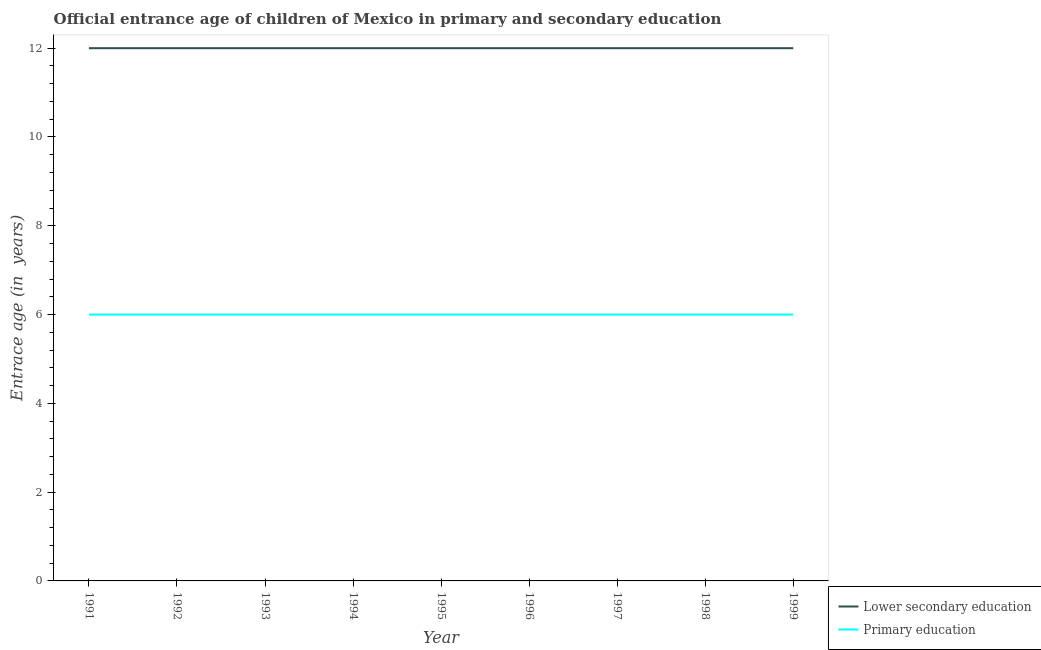Does the line corresponding to entrance age of children in lower secondary education intersect with the line corresponding to entrance age of chiildren in primary education?
Make the answer very short. No. Is the number of lines equal to the number of legend labels?
Keep it short and to the point. Yes. What is the entrance age of children in lower secondary education in 1991?
Your answer should be compact. 12. Across all years, what is the maximum entrance age of children in lower secondary education?
Provide a succinct answer. 12. Across all years, what is the minimum entrance age of chiildren in primary education?
Provide a succinct answer. 6. In which year was the entrance age of chiildren in primary education maximum?
Provide a short and direct response. 1991. In which year was the entrance age of children in lower secondary education minimum?
Make the answer very short. 1991. What is the total entrance age of chiildren in primary education in the graph?
Your answer should be compact. 54. What is the difference between the entrance age of chiildren in primary education in 1997 and the entrance age of children in lower secondary education in 1995?
Give a very brief answer. -6. In the year 1994, what is the difference between the entrance age of chiildren in primary education and entrance age of children in lower secondary education?
Make the answer very short. -6. In how many years, is the entrance age of children in lower secondary education greater than 8.4 years?
Give a very brief answer. 9. Is the difference between the entrance age of children in lower secondary education in 1993 and 1998 greater than the difference between the entrance age of chiildren in primary education in 1993 and 1998?
Your answer should be very brief. No. What is the difference between the highest and the lowest entrance age of chiildren in primary education?
Your response must be concise. 0. Is the sum of the entrance age of chiildren in primary education in 1997 and 1999 greater than the maximum entrance age of children in lower secondary education across all years?
Offer a terse response. No. Does the entrance age of children in lower secondary education monotonically increase over the years?
Your response must be concise. No. Is the entrance age of children in lower secondary education strictly greater than the entrance age of chiildren in primary education over the years?
Your answer should be very brief. Yes. How many lines are there?
Provide a succinct answer. 2. How many years are there in the graph?
Offer a very short reply. 9. What is the difference between two consecutive major ticks on the Y-axis?
Offer a terse response. 2. Are the values on the major ticks of Y-axis written in scientific E-notation?
Your response must be concise. No. Does the graph contain grids?
Provide a short and direct response. No. What is the title of the graph?
Ensure brevity in your answer.  Official entrance age of children of Mexico in primary and secondary education. Does "Passenger Transport Items" appear as one of the legend labels in the graph?
Your answer should be very brief. No. What is the label or title of the Y-axis?
Provide a succinct answer. Entrace age (in  years). What is the Entrace age (in  years) in Lower secondary education in 1991?
Keep it short and to the point. 12. What is the Entrace age (in  years) of Lower secondary education in 1992?
Your answer should be very brief. 12. What is the Entrace age (in  years) in Primary education in 1993?
Give a very brief answer. 6. What is the Entrace age (in  years) in Lower secondary education in 1994?
Your answer should be very brief. 12. What is the Entrace age (in  years) of Lower secondary education in 1995?
Provide a succinct answer. 12. What is the Entrace age (in  years) in Primary education in 1997?
Provide a short and direct response. 6. What is the total Entrace age (in  years) in Lower secondary education in the graph?
Provide a short and direct response. 108. What is the total Entrace age (in  years) of Primary education in the graph?
Ensure brevity in your answer.  54. What is the difference between the Entrace age (in  years) in Primary education in 1991 and that in 1992?
Ensure brevity in your answer.  0. What is the difference between the Entrace age (in  years) in Lower secondary education in 1991 and that in 1994?
Provide a short and direct response. 0. What is the difference between the Entrace age (in  years) of Primary education in 1991 and that in 1994?
Offer a terse response. 0. What is the difference between the Entrace age (in  years) in Lower secondary education in 1991 and that in 1996?
Provide a short and direct response. 0. What is the difference between the Entrace age (in  years) in Primary education in 1991 and that in 1996?
Your answer should be very brief. 0. What is the difference between the Entrace age (in  years) of Primary education in 1991 and that in 1997?
Provide a short and direct response. 0. What is the difference between the Entrace age (in  years) of Lower secondary education in 1991 and that in 1998?
Make the answer very short. 0. What is the difference between the Entrace age (in  years) in Primary education in 1991 and that in 1999?
Your answer should be compact. 0. What is the difference between the Entrace age (in  years) in Lower secondary education in 1992 and that in 1993?
Provide a short and direct response. 0. What is the difference between the Entrace age (in  years) in Primary education in 1992 and that in 1993?
Give a very brief answer. 0. What is the difference between the Entrace age (in  years) of Primary education in 1992 and that in 1994?
Offer a terse response. 0. What is the difference between the Entrace age (in  years) in Lower secondary education in 1992 and that in 1996?
Provide a succinct answer. 0. What is the difference between the Entrace age (in  years) in Primary education in 1992 and that in 1996?
Provide a short and direct response. 0. What is the difference between the Entrace age (in  years) in Primary education in 1992 and that in 1997?
Give a very brief answer. 0. What is the difference between the Entrace age (in  years) of Lower secondary education in 1992 and that in 1998?
Your response must be concise. 0. What is the difference between the Entrace age (in  years) of Lower secondary education in 1992 and that in 1999?
Provide a succinct answer. 0. What is the difference between the Entrace age (in  years) in Primary education in 1992 and that in 1999?
Your response must be concise. 0. What is the difference between the Entrace age (in  years) of Primary education in 1993 and that in 1995?
Offer a very short reply. 0. What is the difference between the Entrace age (in  years) in Lower secondary education in 1993 and that in 1996?
Make the answer very short. 0. What is the difference between the Entrace age (in  years) of Primary education in 1993 and that in 1996?
Keep it short and to the point. 0. What is the difference between the Entrace age (in  years) in Primary education in 1993 and that in 1997?
Your response must be concise. 0. What is the difference between the Entrace age (in  years) of Lower secondary education in 1993 and that in 1998?
Offer a very short reply. 0. What is the difference between the Entrace age (in  years) in Primary education in 1994 and that in 1995?
Provide a short and direct response. 0. What is the difference between the Entrace age (in  years) in Primary education in 1994 and that in 1996?
Provide a succinct answer. 0. What is the difference between the Entrace age (in  years) of Lower secondary education in 1994 and that in 1997?
Provide a short and direct response. 0. What is the difference between the Entrace age (in  years) in Lower secondary education in 1994 and that in 1999?
Make the answer very short. 0. What is the difference between the Entrace age (in  years) in Primary education in 1994 and that in 1999?
Make the answer very short. 0. What is the difference between the Entrace age (in  years) of Lower secondary education in 1995 and that in 1996?
Provide a succinct answer. 0. What is the difference between the Entrace age (in  years) in Primary education in 1995 and that in 1996?
Your answer should be compact. 0. What is the difference between the Entrace age (in  years) of Lower secondary education in 1995 and that in 1997?
Give a very brief answer. 0. What is the difference between the Entrace age (in  years) of Primary education in 1995 and that in 1998?
Offer a very short reply. 0. What is the difference between the Entrace age (in  years) of Lower secondary education in 1995 and that in 1999?
Ensure brevity in your answer.  0. What is the difference between the Entrace age (in  years) of Lower secondary education in 1996 and that in 1997?
Offer a very short reply. 0. What is the difference between the Entrace age (in  years) in Primary education in 1996 and that in 1997?
Provide a succinct answer. 0. What is the difference between the Entrace age (in  years) in Lower secondary education in 1996 and that in 1998?
Provide a succinct answer. 0. What is the difference between the Entrace age (in  years) of Primary education in 1996 and that in 1998?
Your answer should be very brief. 0. What is the difference between the Entrace age (in  years) in Primary education in 1997 and that in 1999?
Your answer should be very brief. 0. What is the difference between the Entrace age (in  years) of Lower secondary education in 1998 and that in 1999?
Your response must be concise. 0. What is the difference between the Entrace age (in  years) in Lower secondary education in 1991 and the Entrace age (in  years) in Primary education in 1992?
Make the answer very short. 6. What is the difference between the Entrace age (in  years) in Lower secondary education in 1991 and the Entrace age (in  years) in Primary education in 1997?
Provide a succinct answer. 6. What is the difference between the Entrace age (in  years) in Lower secondary education in 1991 and the Entrace age (in  years) in Primary education in 1998?
Your response must be concise. 6. What is the difference between the Entrace age (in  years) in Lower secondary education in 1992 and the Entrace age (in  years) in Primary education in 1995?
Your response must be concise. 6. What is the difference between the Entrace age (in  years) of Lower secondary education in 1992 and the Entrace age (in  years) of Primary education in 1999?
Your answer should be very brief. 6. What is the difference between the Entrace age (in  years) in Lower secondary education in 1993 and the Entrace age (in  years) in Primary education in 1996?
Keep it short and to the point. 6. What is the difference between the Entrace age (in  years) in Lower secondary education in 1993 and the Entrace age (in  years) in Primary education in 1997?
Your answer should be very brief. 6. What is the difference between the Entrace age (in  years) in Lower secondary education in 1994 and the Entrace age (in  years) in Primary education in 1995?
Offer a terse response. 6. What is the difference between the Entrace age (in  years) of Lower secondary education in 1994 and the Entrace age (in  years) of Primary education in 1996?
Keep it short and to the point. 6. What is the difference between the Entrace age (in  years) of Lower secondary education in 1994 and the Entrace age (in  years) of Primary education in 1997?
Keep it short and to the point. 6. What is the difference between the Entrace age (in  years) in Lower secondary education in 1994 and the Entrace age (in  years) in Primary education in 1999?
Give a very brief answer. 6. What is the difference between the Entrace age (in  years) of Lower secondary education in 1995 and the Entrace age (in  years) of Primary education in 1996?
Provide a succinct answer. 6. What is the difference between the Entrace age (in  years) of Lower secondary education in 1995 and the Entrace age (in  years) of Primary education in 1997?
Provide a short and direct response. 6. What is the difference between the Entrace age (in  years) of Lower secondary education in 1995 and the Entrace age (in  years) of Primary education in 1998?
Make the answer very short. 6. What is the difference between the Entrace age (in  years) in Lower secondary education in 1996 and the Entrace age (in  years) in Primary education in 1997?
Give a very brief answer. 6. What is the difference between the Entrace age (in  years) in Lower secondary education in 1996 and the Entrace age (in  years) in Primary education in 1998?
Give a very brief answer. 6. What is the difference between the Entrace age (in  years) of Lower secondary education in 1997 and the Entrace age (in  years) of Primary education in 1999?
Your response must be concise. 6. What is the difference between the Entrace age (in  years) in Lower secondary education in 1998 and the Entrace age (in  years) in Primary education in 1999?
Provide a succinct answer. 6. What is the average Entrace age (in  years) of Lower secondary education per year?
Provide a short and direct response. 12. What is the average Entrace age (in  years) in Primary education per year?
Give a very brief answer. 6. In the year 1991, what is the difference between the Entrace age (in  years) in Lower secondary education and Entrace age (in  years) in Primary education?
Your answer should be compact. 6. In the year 1992, what is the difference between the Entrace age (in  years) in Lower secondary education and Entrace age (in  years) in Primary education?
Provide a succinct answer. 6. In the year 1993, what is the difference between the Entrace age (in  years) of Lower secondary education and Entrace age (in  years) of Primary education?
Your response must be concise. 6. In the year 1997, what is the difference between the Entrace age (in  years) of Lower secondary education and Entrace age (in  years) of Primary education?
Offer a terse response. 6. In the year 1998, what is the difference between the Entrace age (in  years) in Lower secondary education and Entrace age (in  years) in Primary education?
Provide a short and direct response. 6. In the year 1999, what is the difference between the Entrace age (in  years) of Lower secondary education and Entrace age (in  years) of Primary education?
Ensure brevity in your answer.  6. What is the ratio of the Entrace age (in  years) in Lower secondary education in 1991 to that in 1992?
Your answer should be very brief. 1. What is the ratio of the Entrace age (in  years) in Primary education in 1991 to that in 1992?
Your answer should be very brief. 1. What is the ratio of the Entrace age (in  years) of Primary education in 1991 to that in 1993?
Keep it short and to the point. 1. What is the ratio of the Entrace age (in  years) in Lower secondary education in 1991 to that in 1994?
Give a very brief answer. 1. What is the ratio of the Entrace age (in  years) of Lower secondary education in 1991 to that in 1995?
Your answer should be compact. 1. What is the ratio of the Entrace age (in  years) of Primary education in 1991 to that in 1995?
Provide a succinct answer. 1. What is the ratio of the Entrace age (in  years) in Lower secondary education in 1991 to that in 1996?
Make the answer very short. 1. What is the ratio of the Entrace age (in  years) in Primary education in 1991 to that in 1996?
Keep it short and to the point. 1. What is the ratio of the Entrace age (in  years) of Lower secondary education in 1991 to that in 1997?
Give a very brief answer. 1. What is the ratio of the Entrace age (in  years) of Primary education in 1991 to that in 1997?
Your response must be concise. 1. What is the ratio of the Entrace age (in  years) in Lower secondary education in 1991 to that in 1998?
Offer a very short reply. 1. What is the ratio of the Entrace age (in  years) in Lower secondary education in 1992 to that in 1993?
Your answer should be compact. 1. What is the ratio of the Entrace age (in  years) in Primary education in 1992 to that in 1993?
Provide a succinct answer. 1. What is the ratio of the Entrace age (in  years) in Primary education in 1992 to that in 1994?
Your answer should be very brief. 1. What is the ratio of the Entrace age (in  years) of Lower secondary education in 1992 to that in 1995?
Provide a succinct answer. 1. What is the ratio of the Entrace age (in  years) of Primary education in 1992 to that in 1995?
Provide a short and direct response. 1. What is the ratio of the Entrace age (in  years) of Lower secondary education in 1992 to that in 1996?
Offer a terse response. 1. What is the ratio of the Entrace age (in  years) of Primary education in 1992 to that in 1998?
Ensure brevity in your answer.  1. What is the ratio of the Entrace age (in  years) in Primary education in 1992 to that in 1999?
Your answer should be compact. 1. What is the ratio of the Entrace age (in  years) in Lower secondary education in 1993 to that in 1995?
Your response must be concise. 1. What is the ratio of the Entrace age (in  years) in Primary education in 1993 to that in 1996?
Give a very brief answer. 1. What is the ratio of the Entrace age (in  years) of Primary education in 1993 to that in 1997?
Your answer should be very brief. 1. What is the ratio of the Entrace age (in  years) in Primary education in 1993 to that in 1998?
Offer a very short reply. 1. What is the ratio of the Entrace age (in  years) in Primary education in 1993 to that in 1999?
Your answer should be very brief. 1. What is the ratio of the Entrace age (in  years) in Lower secondary education in 1994 to that in 1995?
Offer a very short reply. 1. What is the ratio of the Entrace age (in  years) in Primary education in 1994 to that in 1995?
Your response must be concise. 1. What is the ratio of the Entrace age (in  years) of Lower secondary education in 1994 to that in 1996?
Provide a short and direct response. 1. What is the ratio of the Entrace age (in  years) in Lower secondary education in 1994 to that in 1997?
Keep it short and to the point. 1. What is the ratio of the Entrace age (in  years) of Primary education in 1994 to that in 1997?
Your answer should be compact. 1. What is the ratio of the Entrace age (in  years) of Lower secondary education in 1994 to that in 1999?
Provide a short and direct response. 1. What is the ratio of the Entrace age (in  years) of Lower secondary education in 1995 to that in 1996?
Offer a very short reply. 1. What is the ratio of the Entrace age (in  years) in Primary education in 1995 to that in 1996?
Your answer should be compact. 1. What is the ratio of the Entrace age (in  years) in Primary education in 1995 to that in 1997?
Offer a very short reply. 1. What is the ratio of the Entrace age (in  years) of Lower secondary education in 1995 to that in 1998?
Your answer should be very brief. 1. What is the ratio of the Entrace age (in  years) of Lower secondary education in 1995 to that in 1999?
Give a very brief answer. 1. What is the ratio of the Entrace age (in  years) of Primary education in 1995 to that in 1999?
Ensure brevity in your answer.  1. What is the ratio of the Entrace age (in  years) in Primary education in 1996 to that in 1997?
Make the answer very short. 1. What is the ratio of the Entrace age (in  years) of Lower secondary education in 1996 to that in 1998?
Offer a terse response. 1. What is the ratio of the Entrace age (in  years) in Lower secondary education in 1996 to that in 1999?
Give a very brief answer. 1. What is the ratio of the Entrace age (in  years) in Lower secondary education in 1997 to that in 1998?
Provide a short and direct response. 1. What is the ratio of the Entrace age (in  years) in Lower secondary education in 1997 to that in 1999?
Ensure brevity in your answer.  1. What is the ratio of the Entrace age (in  years) of Lower secondary education in 1998 to that in 1999?
Your answer should be very brief. 1. What is the difference between the highest and the lowest Entrace age (in  years) of Lower secondary education?
Make the answer very short. 0. 